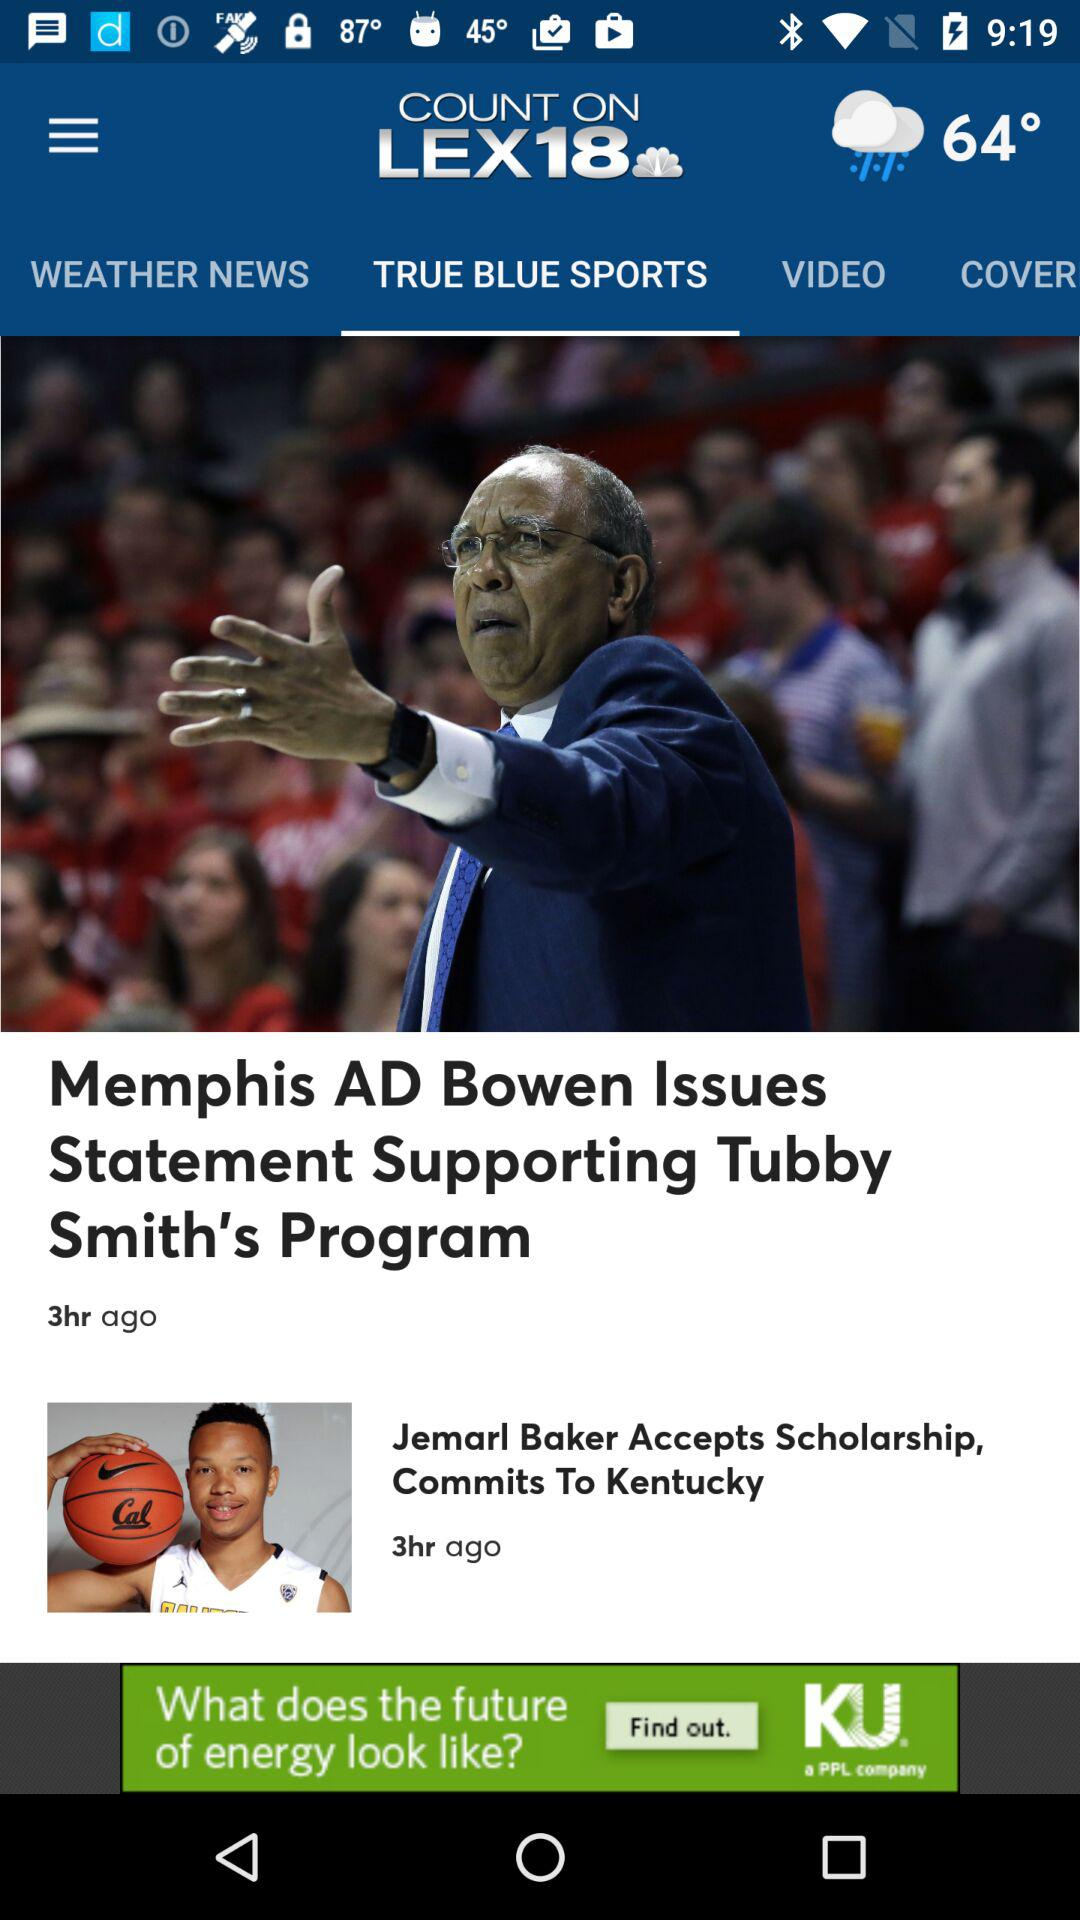How many hours ago was the news posted? The news was posted 3 hours ago. 